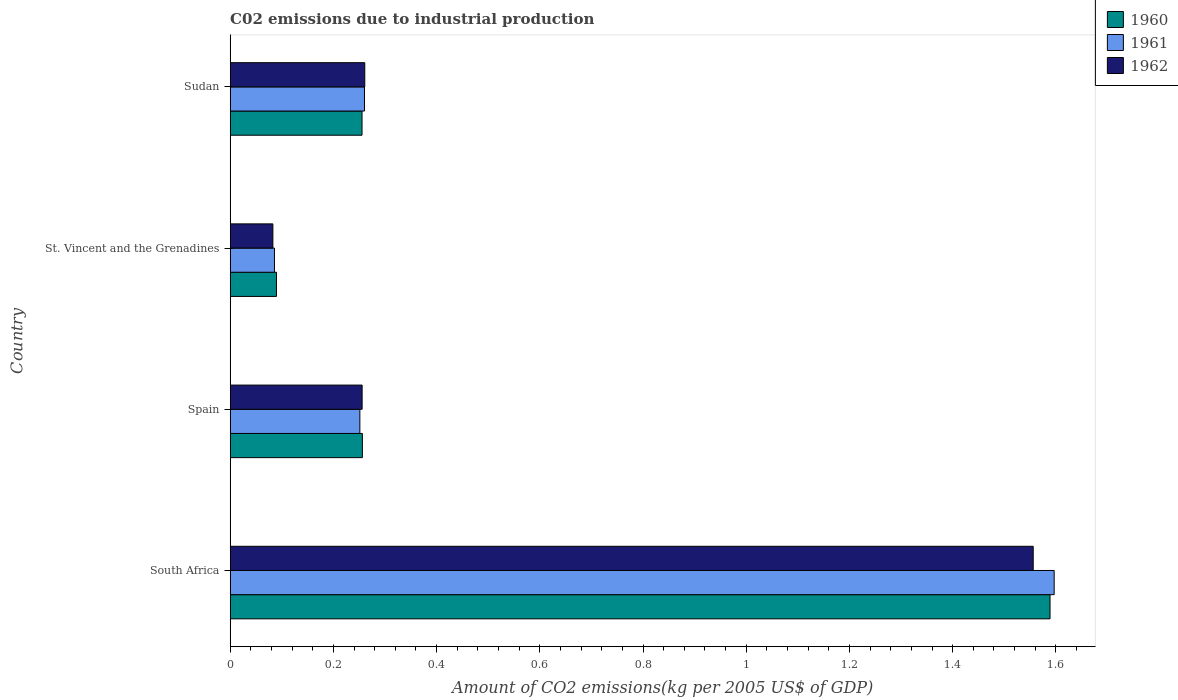How many different coloured bars are there?
Ensure brevity in your answer.  3. How many bars are there on the 3rd tick from the top?
Provide a short and direct response. 3. What is the label of the 1st group of bars from the top?
Provide a short and direct response. Sudan. What is the amount of CO2 emitted due to industrial production in 1960 in Spain?
Keep it short and to the point. 0.26. Across all countries, what is the maximum amount of CO2 emitted due to industrial production in 1961?
Your response must be concise. 1.6. Across all countries, what is the minimum amount of CO2 emitted due to industrial production in 1962?
Keep it short and to the point. 0.08. In which country was the amount of CO2 emitted due to industrial production in 1961 maximum?
Offer a very short reply. South Africa. In which country was the amount of CO2 emitted due to industrial production in 1961 minimum?
Offer a very short reply. St. Vincent and the Grenadines. What is the total amount of CO2 emitted due to industrial production in 1961 in the graph?
Give a very brief answer. 2.19. What is the difference between the amount of CO2 emitted due to industrial production in 1962 in St. Vincent and the Grenadines and that in Sudan?
Ensure brevity in your answer.  -0.18. What is the difference between the amount of CO2 emitted due to industrial production in 1962 in Spain and the amount of CO2 emitted due to industrial production in 1960 in St. Vincent and the Grenadines?
Your response must be concise. 0.17. What is the average amount of CO2 emitted due to industrial production in 1962 per country?
Offer a terse response. 0.54. What is the difference between the amount of CO2 emitted due to industrial production in 1961 and amount of CO2 emitted due to industrial production in 1960 in South Africa?
Provide a succinct answer. 0.01. What is the ratio of the amount of CO2 emitted due to industrial production in 1961 in South Africa to that in Sudan?
Keep it short and to the point. 6.14. Is the amount of CO2 emitted due to industrial production in 1961 in St. Vincent and the Grenadines less than that in Sudan?
Make the answer very short. Yes. What is the difference between the highest and the second highest amount of CO2 emitted due to industrial production in 1962?
Provide a short and direct response. 1.3. What is the difference between the highest and the lowest amount of CO2 emitted due to industrial production in 1962?
Give a very brief answer. 1.47. In how many countries, is the amount of CO2 emitted due to industrial production in 1962 greater than the average amount of CO2 emitted due to industrial production in 1962 taken over all countries?
Your response must be concise. 1. What does the 1st bar from the bottom in Sudan represents?
Your answer should be very brief. 1960. Is it the case that in every country, the sum of the amount of CO2 emitted due to industrial production in 1961 and amount of CO2 emitted due to industrial production in 1962 is greater than the amount of CO2 emitted due to industrial production in 1960?
Offer a very short reply. Yes. How many bars are there?
Provide a succinct answer. 12. Are all the bars in the graph horizontal?
Offer a terse response. Yes. How many countries are there in the graph?
Ensure brevity in your answer.  4. What is the difference between two consecutive major ticks on the X-axis?
Make the answer very short. 0.2. Does the graph contain grids?
Make the answer very short. No. Where does the legend appear in the graph?
Provide a succinct answer. Top right. How many legend labels are there?
Offer a terse response. 3. What is the title of the graph?
Your answer should be very brief. C02 emissions due to industrial production. What is the label or title of the X-axis?
Make the answer very short. Amount of CO2 emissions(kg per 2005 US$ of GDP). What is the Amount of CO2 emissions(kg per 2005 US$ of GDP) in 1960 in South Africa?
Give a very brief answer. 1.59. What is the Amount of CO2 emissions(kg per 2005 US$ of GDP) in 1961 in South Africa?
Offer a very short reply. 1.6. What is the Amount of CO2 emissions(kg per 2005 US$ of GDP) of 1962 in South Africa?
Give a very brief answer. 1.56. What is the Amount of CO2 emissions(kg per 2005 US$ of GDP) of 1960 in Spain?
Offer a very short reply. 0.26. What is the Amount of CO2 emissions(kg per 2005 US$ of GDP) of 1961 in Spain?
Provide a short and direct response. 0.25. What is the Amount of CO2 emissions(kg per 2005 US$ of GDP) of 1962 in Spain?
Your answer should be compact. 0.26. What is the Amount of CO2 emissions(kg per 2005 US$ of GDP) in 1960 in St. Vincent and the Grenadines?
Ensure brevity in your answer.  0.09. What is the Amount of CO2 emissions(kg per 2005 US$ of GDP) in 1961 in St. Vincent and the Grenadines?
Keep it short and to the point. 0.09. What is the Amount of CO2 emissions(kg per 2005 US$ of GDP) of 1962 in St. Vincent and the Grenadines?
Provide a short and direct response. 0.08. What is the Amount of CO2 emissions(kg per 2005 US$ of GDP) in 1960 in Sudan?
Your answer should be compact. 0.26. What is the Amount of CO2 emissions(kg per 2005 US$ of GDP) of 1961 in Sudan?
Keep it short and to the point. 0.26. What is the Amount of CO2 emissions(kg per 2005 US$ of GDP) of 1962 in Sudan?
Provide a succinct answer. 0.26. Across all countries, what is the maximum Amount of CO2 emissions(kg per 2005 US$ of GDP) of 1960?
Make the answer very short. 1.59. Across all countries, what is the maximum Amount of CO2 emissions(kg per 2005 US$ of GDP) of 1961?
Offer a very short reply. 1.6. Across all countries, what is the maximum Amount of CO2 emissions(kg per 2005 US$ of GDP) in 1962?
Provide a short and direct response. 1.56. Across all countries, what is the minimum Amount of CO2 emissions(kg per 2005 US$ of GDP) of 1960?
Keep it short and to the point. 0.09. Across all countries, what is the minimum Amount of CO2 emissions(kg per 2005 US$ of GDP) of 1961?
Provide a short and direct response. 0.09. Across all countries, what is the minimum Amount of CO2 emissions(kg per 2005 US$ of GDP) of 1962?
Provide a short and direct response. 0.08. What is the total Amount of CO2 emissions(kg per 2005 US$ of GDP) in 1960 in the graph?
Provide a short and direct response. 2.19. What is the total Amount of CO2 emissions(kg per 2005 US$ of GDP) of 1961 in the graph?
Give a very brief answer. 2.19. What is the total Amount of CO2 emissions(kg per 2005 US$ of GDP) in 1962 in the graph?
Provide a short and direct response. 2.16. What is the difference between the Amount of CO2 emissions(kg per 2005 US$ of GDP) of 1960 in South Africa and that in Spain?
Keep it short and to the point. 1.33. What is the difference between the Amount of CO2 emissions(kg per 2005 US$ of GDP) of 1961 in South Africa and that in Spain?
Ensure brevity in your answer.  1.35. What is the difference between the Amount of CO2 emissions(kg per 2005 US$ of GDP) in 1962 in South Africa and that in Spain?
Provide a short and direct response. 1.3. What is the difference between the Amount of CO2 emissions(kg per 2005 US$ of GDP) of 1960 in South Africa and that in St. Vincent and the Grenadines?
Provide a short and direct response. 1.5. What is the difference between the Amount of CO2 emissions(kg per 2005 US$ of GDP) of 1961 in South Africa and that in St. Vincent and the Grenadines?
Your answer should be very brief. 1.51. What is the difference between the Amount of CO2 emissions(kg per 2005 US$ of GDP) in 1962 in South Africa and that in St. Vincent and the Grenadines?
Give a very brief answer. 1.47. What is the difference between the Amount of CO2 emissions(kg per 2005 US$ of GDP) in 1960 in South Africa and that in Sudan?
Give a very brief answer. 1.33. What is the difference between the Amount of CO2 emissions(kg per 2005 US$ of GDP) in 1961 in South Africa and that in Sudan?
Provide a succinct answer. 1.34. What is the difference between the Amount of CO2 emissions(kg per 2005 US$ of GDP) of 1962 in South Africa and that in Sudan?
Your answer should be compact. 1.3. What is the difference between the Amount of CO2 emissions(kg per 2005 US$ of GDP) of 1960 in Spain and that in St. Vincent and the Grenadines?
Make the answer very short. 0.17. What is the difference between the Amount of CO2 emissions(kg per 2005 US$ of GDP) of 1961 in Spain and that in St. Vincent and the Grenadines?
Provide a short and direct response. 0.17. What is the difference between the Amount of CO2 emissions(kg per 2005 US$ of GDP) in 1962 in Spain and that in St. Vincent and the Grenadines?
Provide a succinct answer. 0.17. What is the difference between the Amount of CO2 emissions(kg per 2005 US$ of GDP) in 1960 in Spain and that in Sudan?
Your answer should be compact. 0. What is the difference between the Amount of CO2 emissions(kg per 2005 US$ of GDP) of 1961 in Spain and that in Sudan?
Provide a succinct answer. -0.01. What is the difference between the Amount of CO2 emissions(kg per 2005 US$ of GDP) of 1962 in Spain and that in Sudan?
Provide a succinct answer. -0.01. What is the difference between the Amount of CO2 emissions(kg per 2005 US$ of GDP) of 1960 in St. Vincent and the Grenadines and that in Sudan?
Offer a very short reply. -0.17. What is the difference between the Amount of CO2 emissions(kg per 2005 US$ of GDP) in 1961 in St. Vincent and the Grenadines and that in Sudan?
Provide a short and direct response. -0.17. What is the difference between the Amount of CO2 emissions(kg per 2005 US$ of GDP) in 1962 in St. Vincent and the Grenadines and that in Sudan?
Your answer should be very brief. -0.18. What is the difference between the Amount of CO2 emissions(kg per 2005 US$ of GDP) in 1960 in South Africa and the Amount of CO2 emissions(kg per 2005 US$ of GDP) in 1961 in Spain?
Ensure brevity in your answer.  1.34. What is the difference between the Amount of CO2 emissions(kg per 2005 US$ of GDP) in 1960 in South Africa and the Amount of CO2 emissions(kg per 2005 US$ of GDP) in 1962 in Spain?
Keep it short and to the point. 1.33. What is the difference between the Amount of CO2 emissions(kg per 2005 US$ of GDP) in 1961 in South Africa and the Amount of CO2 emissions(kg per 2005 US$ of GDP) in 1962 in Spain?
Give a very brief answer. 1.34. What is the difference between the Amount of CO2 emissions(kg per 2005 US$ of GDP) of 1960 in South Africa and the Amount of CO2 emissions(kg per 2005 US$ of GDP) of 1961 in St. Vincent and the Grenadines?
Make the answer very short. 1.5. What is the difference between the Amount of CO2 emissions(kg per 2005 US$ of GDP) in 1960 in South Africa and the Amount of CO2 emissions(kg per 2005 US$ of GDP) in 1962 in St. Vincent and the Grenadines?
Provide a succinct answer. 1.51. What is the difference between the Amount of CO2 emissions(kg per 2005 US$ of GDP) in 1961 in South Africa and the Amount of CO2 emissions(kg per 2005 US$ of GDP) in 1962 in St. Vincent and the Grenadines?
Give a very brief answer. 1.51. What is the difference between the Amount of CO2 emissions(kg per 2005 US$ of GDP) in 1960 in South Africa and the Amount of CO2 emissions(kg per 2005 US$ of GDP) in 1961 in Sudan?
Give a very brief answer. 1.33. What is the difference between the Amount of CO2 emissions(kg per 2005 US$ of GDP) in 1960 in South Africa and the Amount of CO2 emissions(kg per 2005 US$ of GDP) in 1962 in Sudan?
Your answer should be compact. 1.33. What is the difference between the Amount of CO2 emissions(kg per 2005 US$ of GDP) in 1961 in South Africa and the Amount of CO2 emissions(kg per 2005 US$ of GDP) in 1962 in Sudan?
Provide a short and direct response. 1.34. What is the difference between the Amount of CO2 emissions(kg per 2005 US$ of GDP) in 1960 in Spain and the Amount of CO2 emissions(kg per 2005 US$ of GDP) in 1961 in St. Vincent and the Grenadines?
Ensure brevity in your answer.  0.17. What is the difference between the Amount of CO2 emissions(kg per 2005 US$ of GDP) in 1960 in Spain and the Amount of CO2 emissions(kg per 2005 US$ of GDP) in 1962 in St. Vincent and the Grenadines?
Offer a terse response. 0.17. What is the difference between the Amount of CO2 emissions(kg per 2005 US$ of GDP) in 1961 in Spain and the Amount of CO2 emissions(kg per 2005 US$ of GDP) in 1962 in St. Vincent and the Grenadines?
Provide a succinct answer. 0.17. What is the difference between the Amount of CO2 emissions(kg per 2005 US$ of GDP) in 1960 in Spain and the Amount of CO2 emissions(kg per 2005 US$ of GDP) in 1961 in Sudan?
Keep it short and to the point. -0. What is the difference between the Amount of CO2 emissions(kg per 2005 US$ of GDP) in 1960 in Spain and the Amount of CO2 emissions(kg per 2005 US$ of GDP) in 1962 in Sudan?
Your answer should be very brief. -0. What is the difference between the Amount of CO2 emissions(kg per 2005 US$ of GDP) in 1961 in Spain and the Amount of CO2 emissions(kg per 2005 US$ of GDP) in 1962 in Sudan?
Ensure brevity in your answer.  -0.01. What is the difference between the Amount of CO2 emissions(kg per 2005 US$ of GDP) of 1960 in St. Vincent and the Grenadines and the Amount of CO2 emissions(kg per 2005 US$ of GDP) of 1961 in Sudan?
Keep it short and to the point. -0.17. What is the difference between the Amount of CO2 emissions(kg per 2005 US$ of GDP) of 1960 in St. Vincent and the Grenadines and the Amount of CO2 emissions(kg per 2005 US$ of GDP) of 1962 in Sudan?
Your response must be concise. -0.17. What is the difference between the Amount of CO2 emissions(kg per 2005 US$ of GDP) in 1961 in St. Vincent and the Grenadines and the Amount of CO2 emissions(kg per 2005 US$ of GDP) in 1962 in Sudan?
Offer a terse response. -0.17. What is the average Amount of CO2 emissions(kg per 2005 US$ of GDP) of 1960 per country?
Keep it short and to the point. 0.55. What is the average Amount of CO2 emissions(kg per 2005 US$ of GDP) in 1961 per country?
Your answer should be very brief. 0.55. What is the average Amount of CO2 emissions(kg per 2005 US$ of GDP) in 1962 per country?
Offer a terse response. 0.54. What is the difference between the Amount of CO2 emissions(kg per 2005 US$ of GDP) in 1960 and Amount of CO2 emissions(kg per 2005 US$ of GDP) in 1961 in South Africa?
Make the answer very short. -0.01. What is the difference between the Amount of CO2 emissions(kg per 2005 US$ of GDP) of 1960 and Amount of CO2 emissions(kg per 2005 US$ of GDP) of 1962 in South Africa?
Offer a very short reply. 0.03. What is the difference between the Amount of CO2 emissions(kg per 2005 US$ of GDP) in 1961 and Amount of CO2 emissions(kg per 2005 US$ of GDP) in 1962 in South Africa?
Provide a short and direct response. 0.04. What is the difference between the Amount of CO2 emissions(kg per 2005 US$ of GDP) of 1960 and Amount of CO2 emissions(kg per 2005 US$ of GDP) of 1961 in Spain?
Ensure brevity in your answer.  0. What is the difference between the Amount of CO2 emissions(kg per 2005 US$ of GDP) in 1960 and Amount of CO2 emissions(kg per 2005 US$ of GDP) in 1962 in Spain?
Provide a succinct answer. 0. What is the difference between the Amount of CO2 emissions(kg per 2005 US$ of GDP) of 1961 and Amount of CO2 emissions(kg per 2005 US$ of GDP) of 1962 in Spain?
Provide a succinct answer. -0. What is the difference between the Amount of CO2 emissions(kg per 2005 US$ of GDP) of 1960 and Amount of CO2 emissions(kg per 2005 US$ of GDP) of 1961 in St. Vincent and the Grenadines?
Offer a terse response. 0. What is the difference between the Amount of CO2 emissions(kg per 2005 US$ of GDP) of 1960 and Amount of CO2 emissions(kg per 2005 US$ of GDP) of 1962 in St. Vincent and the Grenadines?
Your answer should be compact. 0.01. What is the difference between the Amount of CO2 emissions(kg per 2005 US$ of GDP) of 1961 and Amount of CO2 emissions(kg per 2005 US$ of GDP) of 1962 in St. Vincent and the Grenadines?
Offer a terse response. 0. What is the difference between the Amount of CO2 emissions(kg per 2005 US$ of GDP) in 1960 and Amount of CO2 emissions(kg per 2005 US$ of GDP) in 1961 in Sudan?
Your answer should be compact. -0. What is the difference between the Amount of CO2 emissions(kg per 2005 US$ of GDP) of 1960 and Amount of CO2 emissions(kg per 2005 US$ of GDP) of 1962 in Sudan?
Make the answer very short. -0.01. What is the difference between the Amount of CO2 emissions(kg per 2005 US$ of GDP) of 1961 and Amount of CO2 emissions(kg per 2005 US$ of GDP) of 1962 in Sudan?
Give a very brief answer. -0. What is the ratio of the Amount of CO2 emissions(kg per 2005 US$ of GDP) of 1960 in South Africa to that in Spain?
Your response must be concise. 6.2. What is the ratio of the Amount of CO2 emissions(kg per 2005 US$ of GDP) in 1961 in South Africa to that in Spain?
Keep it short and to the point. 6.35. What is the ratio of the Amount of CO2 emissions(kg per 2005 US$ of GDP) of 1962 in South Africa to that in Spain?
Ensure brevity in your answer.  6.09. What is the ratio of the Amount of CO2 emissions(kg per 2005 US$ of GDP) in 1960 in South Africa to that in St. Vincent and the Grenadines?
Your answer should be compact. 17.72. What is the ratio of the Amount of CO2 emissions(kg per 2005 US$ of GDP) of 1961 in South Africa to that in St. Vincent and the Grenadines?
Your response must be concise. 18.61. What is the ratio of the Amount of CO2 emissions(kg per 2005 US$ of GDP) of 1962 in South Africa to that in St. Vincent and the Grenadines?
Offer a terse response. 18.81. What is the ratio of the Amount of CO2 emissions(kg per 2005 US$ of GDP) of 1960 in South Africa to that in Sudan?
Offer a terse response. 6.22. What is the ratio of the Amount of CO2 emissions(kg per 2005 US$ of GDP) in 1961 in South Africa to that in Sudan?
Your answer should be compact. 6.14. What is the ratio of the Amount of CO2 emissions(kg per 2005 US$ of GDP) of 1962 in South Africa to that in Sudan?
Make the answer very short. 5.97. What is the ratio of the Amount of CO2 emissions(kg per 2005 US$ of GDP) of 1960 in Spain to that in St. Vincent and the Grenadines?
Offer a terse response. 2.86. What is the ratio of the Amount of CO2 emissions(kg per 2005 US$ of GDP) of 1961 in Spain to that in St. Vincent and the Grenadines?
Provide a succinct answer. 2.93. What is the ratio of the Amount of CO2 emissions(kg per 2005 US$ of GDP) of 1962 in Spain to that in St. Vincent and the Grenadines?
Your answer should be compact. 3.09. What is the ratio of the Amount of CO2 emissions(kg per 2005 US$ of GDP) in 1960 in Spain to that in Sudan?
Offer a very short reply. 1. What is the ratio of the Amount of CO2 emissions(kg per 2005 US$ of GDP) in 1961 in Spain to that in Sudan?
Give a very brief answer. 0.97. What is the ratio of the Amount of CO2 emissions(kg per 2005 US$ of GDP) of 1962 in Spain to that in Sudan?
Keep it short and to the point. 0.98. What is the ratio of the Amount of CO2 emissions(kg per 2005 US$ of GDP) in 1960 in St. Vincent and the Grenadines to that in Sudan?
Offer a terse response. 0.35. What is the ratio of the Amount of CO2 emissions(kg per 2005 US$ of GDP) of 1961 in St. Vincent and the Grenadines to that in Sudan?
Offer a very short reply. 0.33. What is the ratio of the Amount of CO2 emissions(kg per 2005 US$ of GDP) of 1962 in St. Vincent and the Grenadines to that in Sudan?
Your answer should be very brief. 0.32. What is the difference between the highest and the second highest Amount of CO2 emissions(kg per 2005 US$ of GDP) of 1960?
Offer a very short reply. 1.33. What is the difference between the highest and the second highest Amount of CO2 emissions(kg per 2005 US$ of GDP) in 1961?
Give a very brief answer. 1.34. What is the difference between the highest and the second highest Amount of CO2 emissions(kg per 2005 US$ of GDP) of 1962?
Ensure brevity in your answer.  1.3. What is the difference between the highest and the lowest Amount of CO2 emissions(kg per 2005 US$ of GDP) of 1960?
Your answer should be very brief. 1.5. What is the difference between the highest and the lowest Amount of CO2 emissions(kg per 2005 US$ of GDP) of 1961?
Your answer should be compact. 1.51. What is the difference between the highest and the lowest Amount of CO2 emissions(kg per 2005 US$ of GDP) in 1962?
Offer a very short reply. 1.47. 